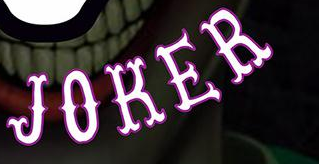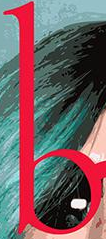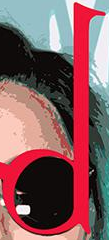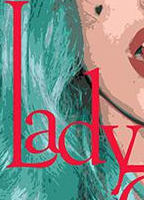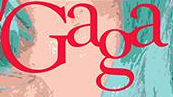Identify the words shown in these images in order, separated by a semicolon. JOKER; b; d; Lady; Gaga 